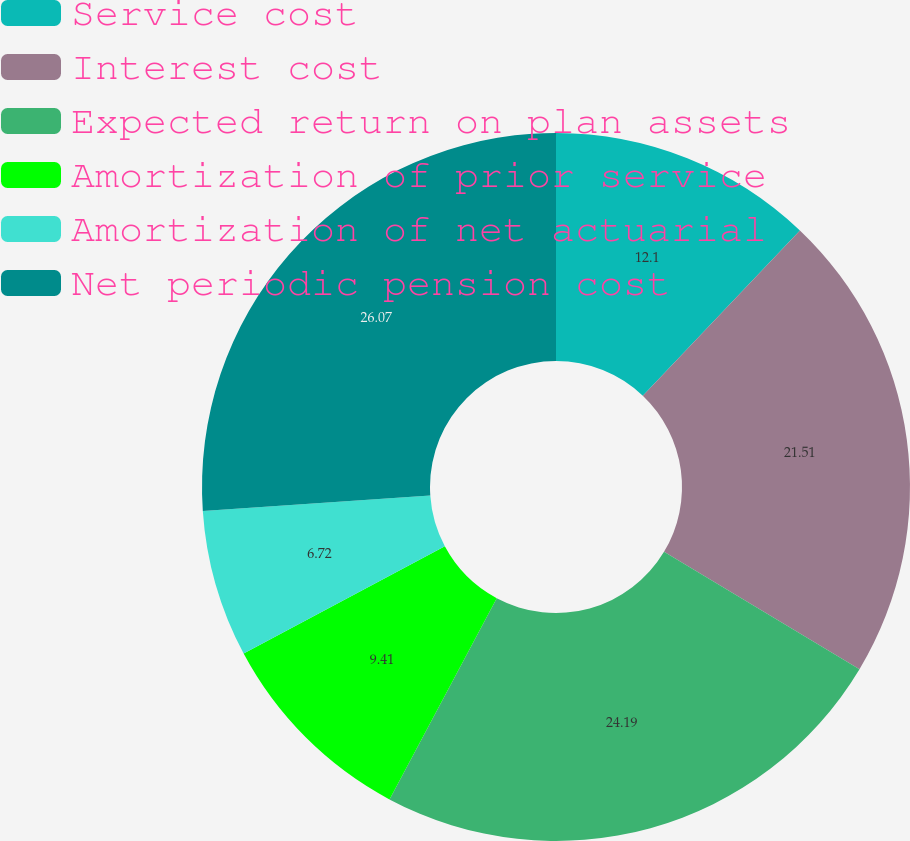Convert chart to OTSL. <chart><loc_0><loc_0><loc_500><loc_500><pie_chart><fcel>Service cost<fcel>Interest cost<fcel>Expected return on plan assets<fcel>Amortization of prior service<fcel>Amortization of net actuarial<fcel>Net periodic pension cost<nl><fcel>12.1%<fcel>21.51%<fcel>24.19%<fcel>9.41%<fcel>6.72%<fcel>26.08%<nl></chart> 